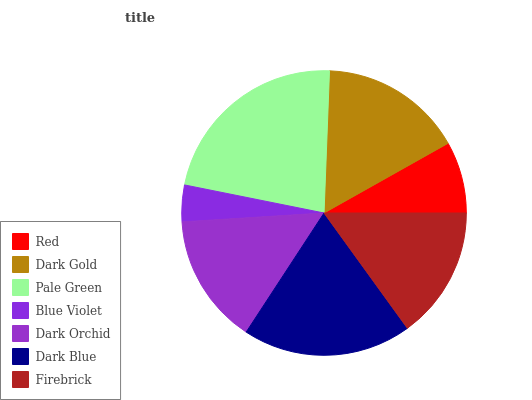Is Blue Violet the minimum?
Answer yes or no. Yes. Is Pale Green the maximum?
Answer yes or no. Yes. Is Dark Gold the minimum?
Answer yes or no. No. Is Dark Gold the maximum?
Answer yes or no. No. Is Dark Gold greater than Red?
Answer yes or no. Yes. Is Red less than Dark Gold?
Answer yes or no. Yes. Is Red greater than Dark Gold?
Answer yes or no. No. Is Dark Gold less than Red?
Answer yes or no. No. Is Firebrick the high median?
Answer yes or no. Yes. Is Firebrick the low median?
Answer yes or no. Yes. Is Blue Violet the high median?
Answer yes or no. No. Is Red the low median?
Answer yes or no. No. 